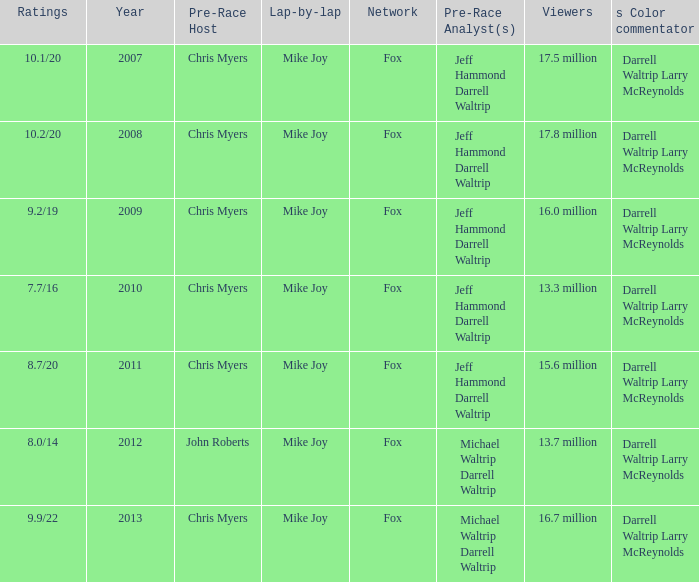How many Ratings did the 2013 Year have? 9.9/22. 